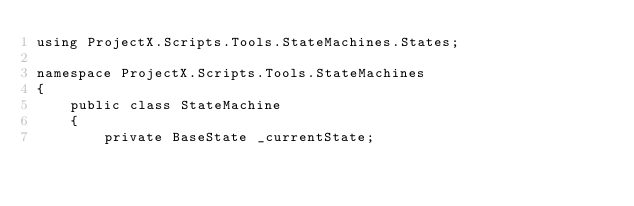<code> <loc_0><loc_0><loc_500><loc_500><_C#_>using ProjectX.Scripts.Tools.StateMachines.States;

namespace ProjectX.Scripts.Tools.StateMachines
{
    public class StateMachine
    {
        private BaseState _currentState;
</code> 